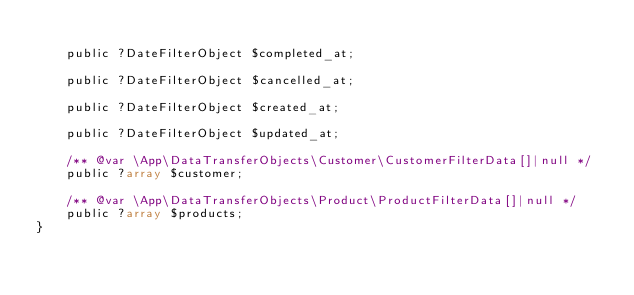<code> <loc_0><loc_0><loc_500><loc_500><_PHP_>
    public ?DateFilterObject $completed_at;

    public ?DateFilterObject $cancelled_at;

    public ?DateFilterObject $created_at;

    public ?DateFilterObject $updated_at;

    /** @var \App\DataTransferObjects\Customer\CustomerFilterData[]|null */
    public ?array $customer;

    /** @var \App\DataTransferObjects\Product\ProductFilterData[]|null */
    public ?array $products;
}
</code> 